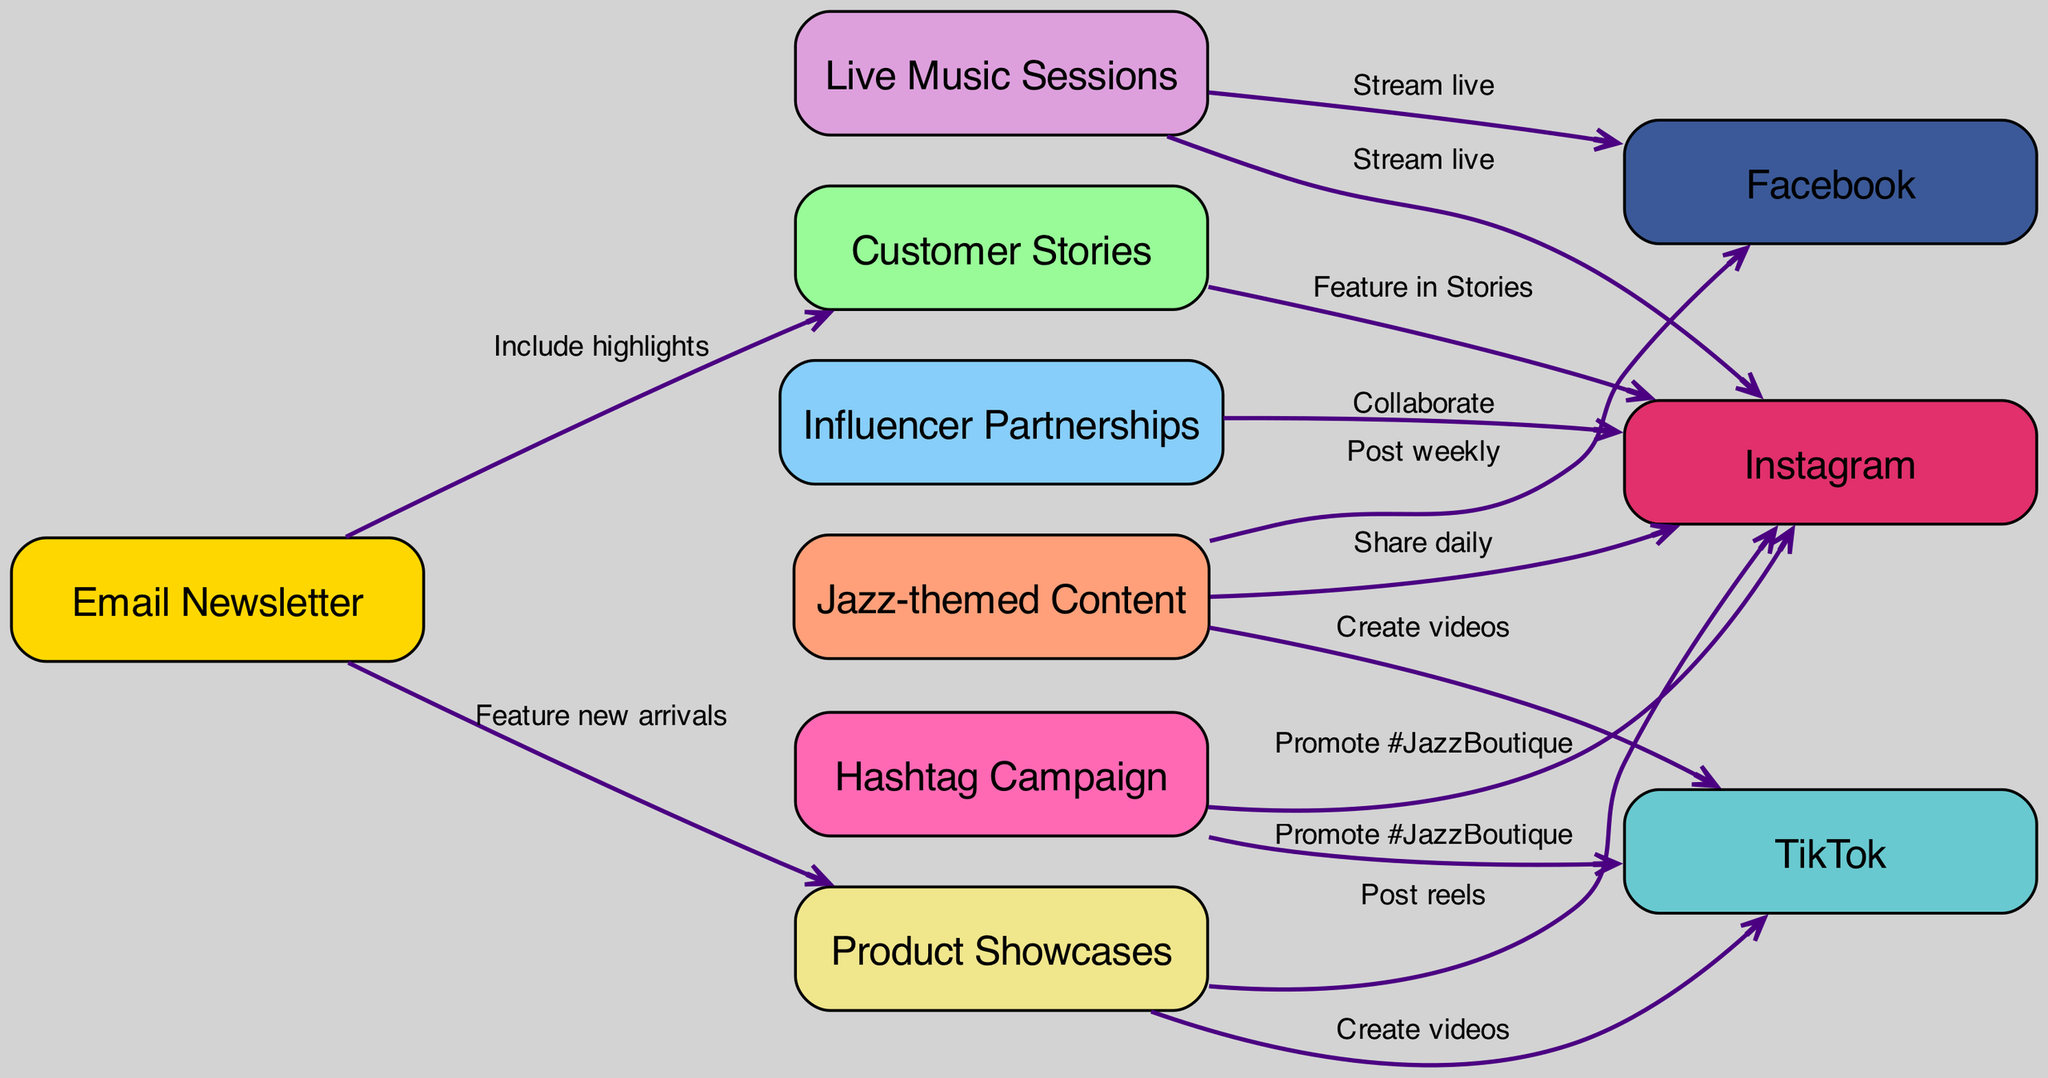What is the total number of nodes in the diagram? The diagram lists all the nodes provided in the data under the "nodes" section. There are 10 distinct entries: "Jazz-themed Content", "Instagram", "Facebook", "TikTok", "Customer Stories", "Live Music Sessions", "Product Showcases", "Influencer Partnerships", "Hashtag Campaign", and "Email Newsletter". Counting these gives a total of 10 nodes.
Answer: 10 Which platform is connected to "Live Music Sessions"? The edges in the diagram show the connections from "Live Music Sessions" to other nodes. The connections indicate that "Live Music Sessions" streams live on both "Instagram" and "Facebook". Thus, there are two platforms connected to it.
Answer: Instagram, Facebook What type of content is used for the "Email Newsletter"? The connections from "Email Newsletter" show that it includes highlights from "Customer Stories" and features "Product Showcases". Thus, the content types are derived from these two nodes.
Answer: Customer Stories, Product Showcases How many edges are directed from "Jazz-themed Content"? The edges indicate how many times "Jazz-themed Content" connects to other nodes. By examining the diagram, "Jazz-themed Content" directs to three edges: "Instagram", "Facebook", and "TikTok". Thus, there are three edges stemming from this node.
Answer: 3 What is the relationship between "Hashtag Campaign" and "TikTok"? The edge indicates that "Hashtag Campaign" promotes the hashtag "#JazzBoutique" on "TikTok". This relationship is clearly defined in the diagram and shows a direct connection suggesting promotion activity between these two nodes.
Answer: Promote #JazzBoutique How does "Influencer Partnerships" relate to "Instagram"? The diagram shows that "Influencer Partnerships" has a connection to "Instagram" through a collaboration edge. This relationship allows for joint marketing efforts, where influencers can help boost visibility for the boutique on this platform.
Answer: Collaborate Which two nodes receive content from "Email Newsletter"? The edges from "Email Newsletter" indicate that it directs its content to "Customer Stories" and "Product Showcases". These connections highlight how the newsletter serves as a vehicle for these specific content types.
Answer: Customer Stories, Product Showcases Is there any content type that connects directly to both "Facebook" and "Instagram"? Analyzing the edges leading to both "Facebook" and "Instagram", it's clear that both "Live Music Sessions" and "Jazz-themed Content" are linked to these two platforms. This indicates a coordinated strategy to engage the audience on both sides simultaneously.
Answer: Live Music Sessions, Jazz-themed Content 